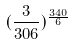<formula> <loc_0><loc_0><loc_500><loc_500>( \frac { 3 } { 3 0 6 } ) ^ { \frac { 3 4 0 } { 6 } }</formula> 